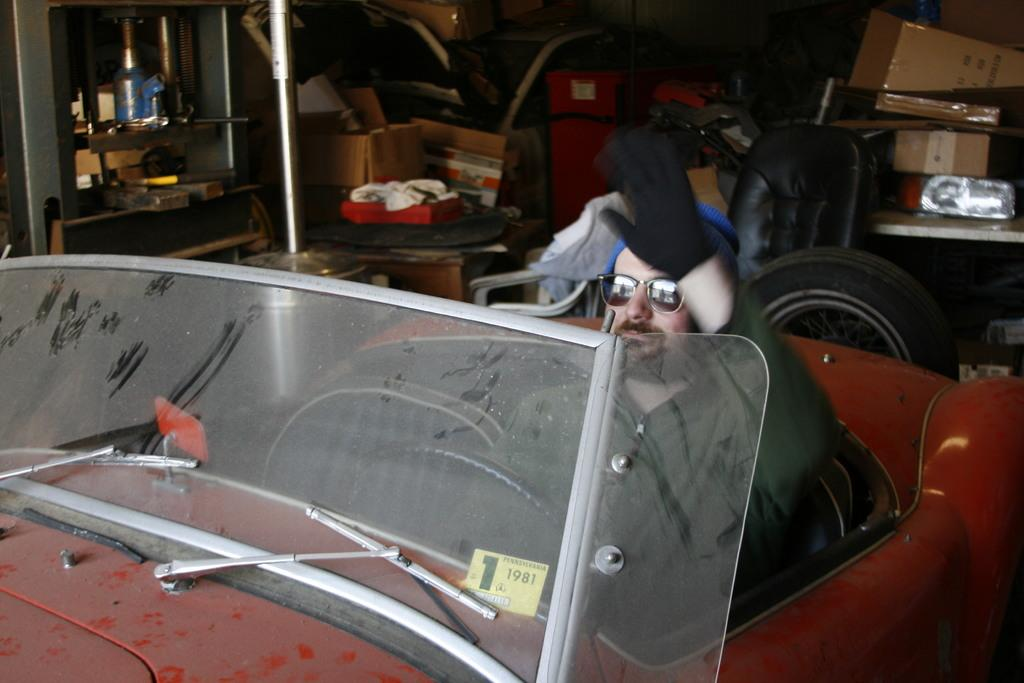What is the person in the image doing? The person is sitting in a car. What is the person wearing on their upper body? The person is wearing a shirt. What type of accessory is the person wearing on their hand? The person is wearing a glove. What objects can be seen behind the person? There is a tire, a chair, a carton, and other objects visible behind the person. How does the person's toe affect the bridge in the image? There is no bridge present in the image, and therefore no impact on it by the person's toe. 